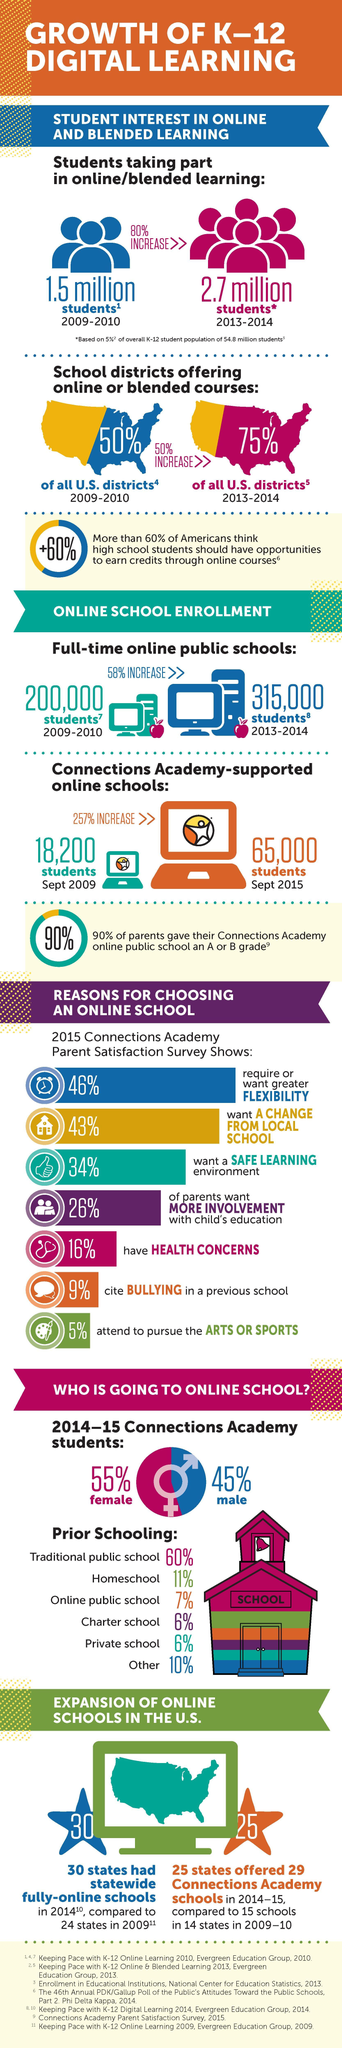What is the rise in the number of  K-12 students participating in online learning from 2009-10 to 2013-14?
Answer the question with a short phrase. 1.2 million What is the total percentage of parents who wanted shift from a regular school to online school for safety and health reasons? 50% How many students have increased in fulltime online public school since 2009-10 to 2013-14? 1,15,000 students What is differences in the percentage of females and males attending online school? 10% What is the increase in the number of students in Connections Academy supported online schools from Sep 2009 to Sep 2015? 46,800 